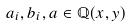<formula> <loc_0><loc_0><loc_500><loc_500>a _ { i } , b _ { i } , a \in \mathbb { Q } ( x , y )</formula> 